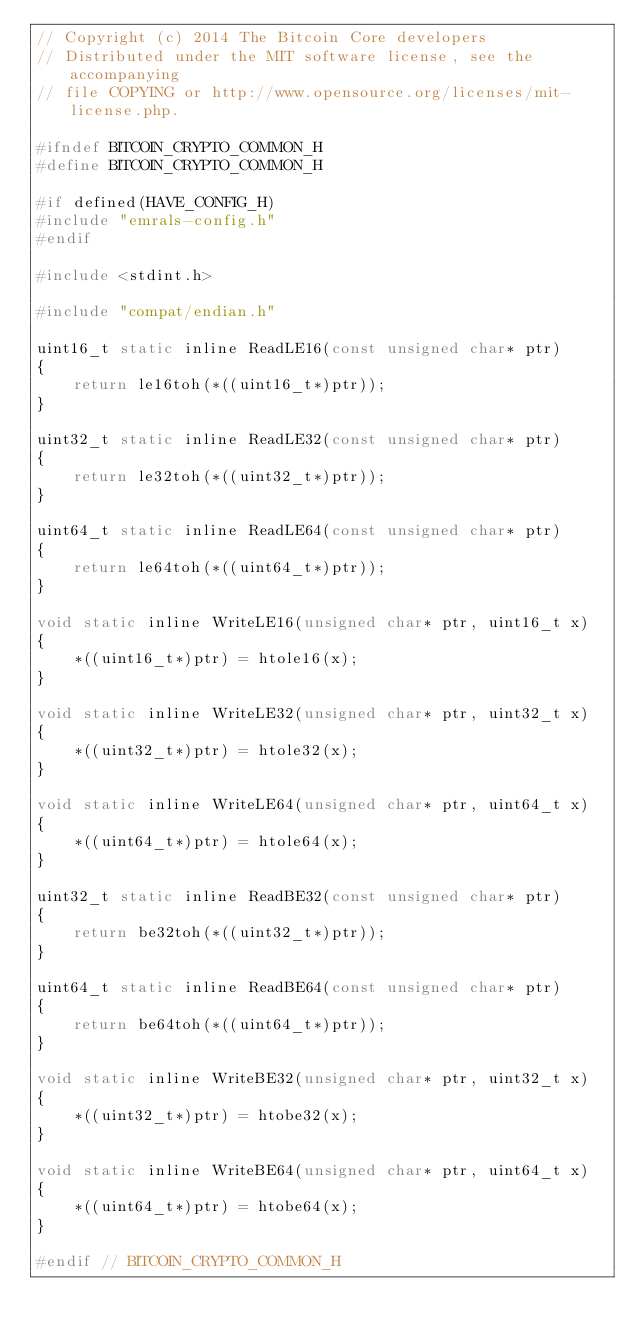Convert code to text. <code><loc_0><loc_0><loc_500><loc_500><_C_>// Copyright (c) 2014 The Bitcoin Core developers
// Distributed under the MIT software license, see the accompanying
// file COPYING or http://www.opensource.org/licenses/mit-license.php.

#ifndef BITCOIN_CRYPTO_COMMON_H
#define BITCOIN_CRYPTO_COMMON_H

#if defined(HAVE_CONFIG_H)
#include "emrals-config.h"
#endif

#include <stdint.h>

#include "compat/endian.h"

uint16_t static inline ReadLE16(const unsigned char* ptr)
{
    return le16toh(*((uint16_t*)ptr));
}

uint32_t static inline ReadLE32(const unsigned char* ptr)
{
    return le32toh(*((uint32_t*)ptr));
}

uint64_t static inline ReadLE64(const unsigned char* ptr)
{
    return le64toh(*((uint64_t*)ptr));
}

void static inline WriteLE16(unsigned char* ptr, uint16_t x)
{
    *((uint16_t*)ptr) = htole16(x);
}

void static inline WriteLE32(unsigned char* ptr, uint32_t x)
{
    *((uint32_t*)ptr) = htole32(x);
}

void static inline WriteLE64(unsigned char* ptr, uint64_t x)
{
    *((uint64_t*)ptr) = htole64(x);
}

uint32_t static inline ReadBE32(const unsigned char* ptr)
{
    return be32toh(*((uint32_t*)ptr));
}

uint64_t static inline ReadBE64(const unsigned char* ptr)
{
    return be64toh(*((uint64_t*)ptr));
}

void static inline WriteBE32(unsigned char* ptr, uint32_t x)
{
    *((uint32_t*)ptr) = htobe32(x);
}

void static inline WriteBE64(unsigned char* ptr, uint64_t x)
{
    *((uint64_t*)ptr) = htobe64(x);
}

#endif // BITCOIN_CRYPTO_COMMON_H
</code> 